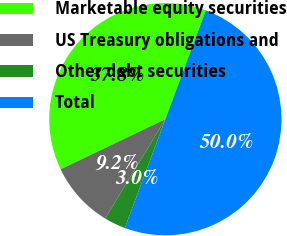Convert chart. <chart><loc_0><loc_0><loc_500><loc_500><pie_chart><fcel>Marketable equity securities<fcel>US Treasury obligations and<fcel>Other debt securities<fcel>Total<nl><fcel>37.77%<fcel>9.24%<fcel>2.99%<fcel>50.0%<nl></chart> 